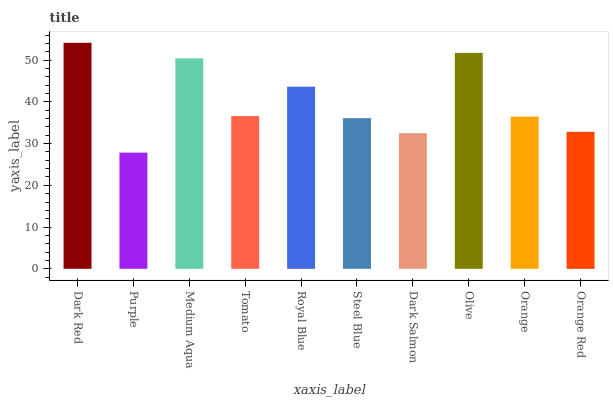Is Purple the minimum?
Answer yes or no. Yes. Is Dark Red the maximum?
Answer yes or no. Yes. Is Medium Aqua the minimum?
Answer yes or no. No. Is Medium Aqua the maximum?
Answer yes or no. No. Is Medium Aqua greater than Purple?
Answer yes or no. Yes. Is Purple less than Medium Aqua?
Answer yes or no. Yes. Is Purple greater than Medium Aqua?
Answer yes or no. No. Is Medium Aqua less than Purple?
Answer yes or no. No. Is Tomato the high median?
Answer yes or no. Yes. Is Orange the low median?
Answer yes or no. Yes. Is Purple the high median?
Answer yes or no. No. Is Tomato the low median?
Answer yes or no. No. 